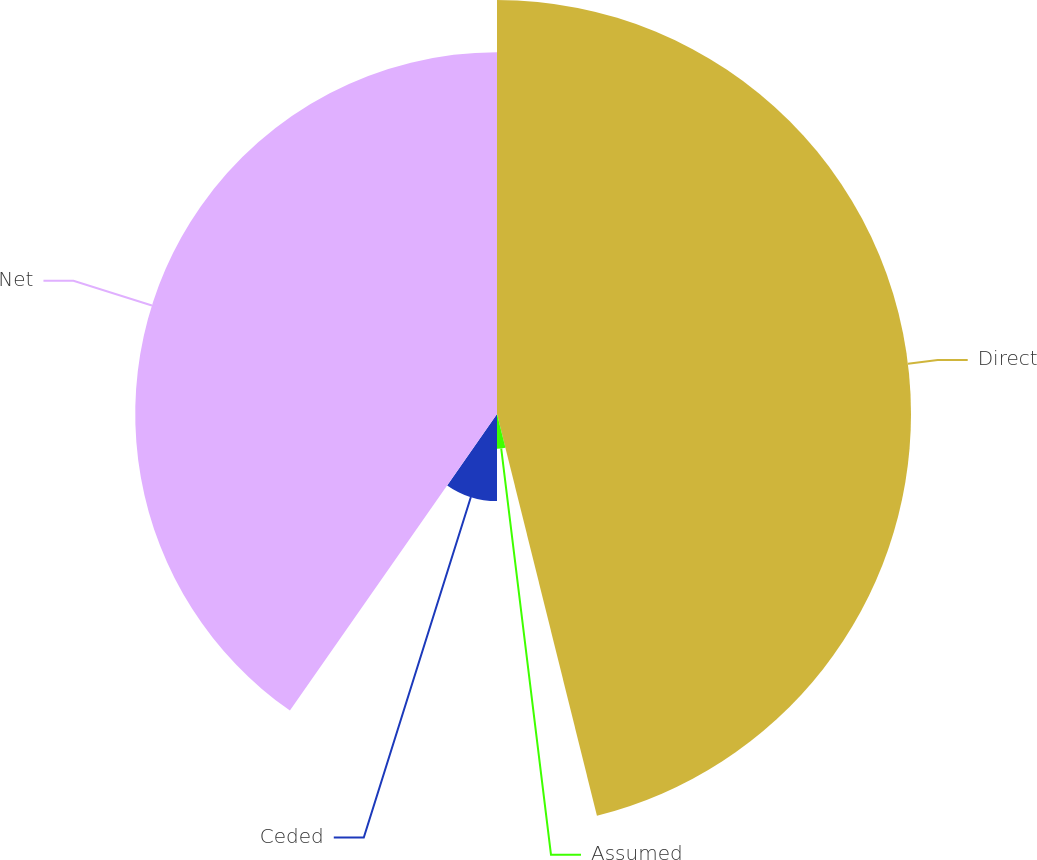<chart> <loc_0><loc_0><loc_500><loc_500><pie_chart><fcel>Direct<fcel>Assumed<fcel>Ceded<fcel>Net<nl><fcel>46.12%<fcel>3.88%<fcel>9.7%<fcel>40.3%<nl></chart> 